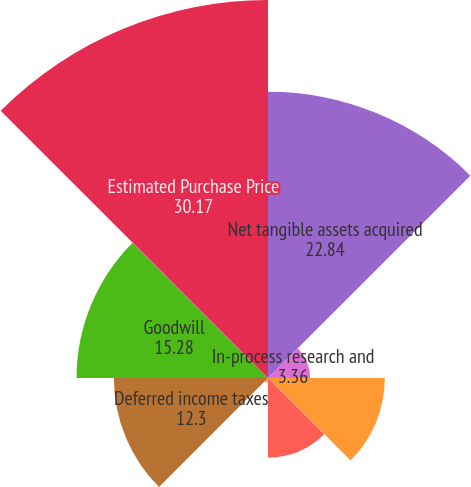<chart> <loc_0><loc_0><loc_500><loc_500><pie_chart><fcel>Net tangible assets acquired<fcel>In-process research and<fcel>Developed technology and know<fcel>Customer relationship<fcel>Trade name<fcel>Deferred income taxes<fcel>Goodwill<fcel>Estimated Purchase Price<nl><fcel>22.84%<fcel>3.36%<fcel>9.32%<fcel>6.34%<fcel>0.39%<fcel>12.3%<fcel>15.28%<fcel>30.17%<nl></chart> 